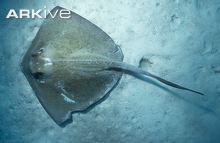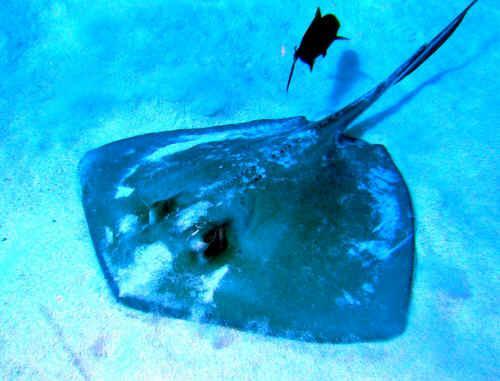The first image is the image on the left, the second image is the image on the right. Assess this claim about the two images: "An image shows one stingray facing rightward, which is not covered with sand.". Correct or not? Answer yes or no. No. The first image is the image on the left, the second image is the image on the right. Considering the images on both sides, is "There's a blue ray and a brown/grey ray, swimming over smooth sand." valid? Answer yes or no. Yes. 